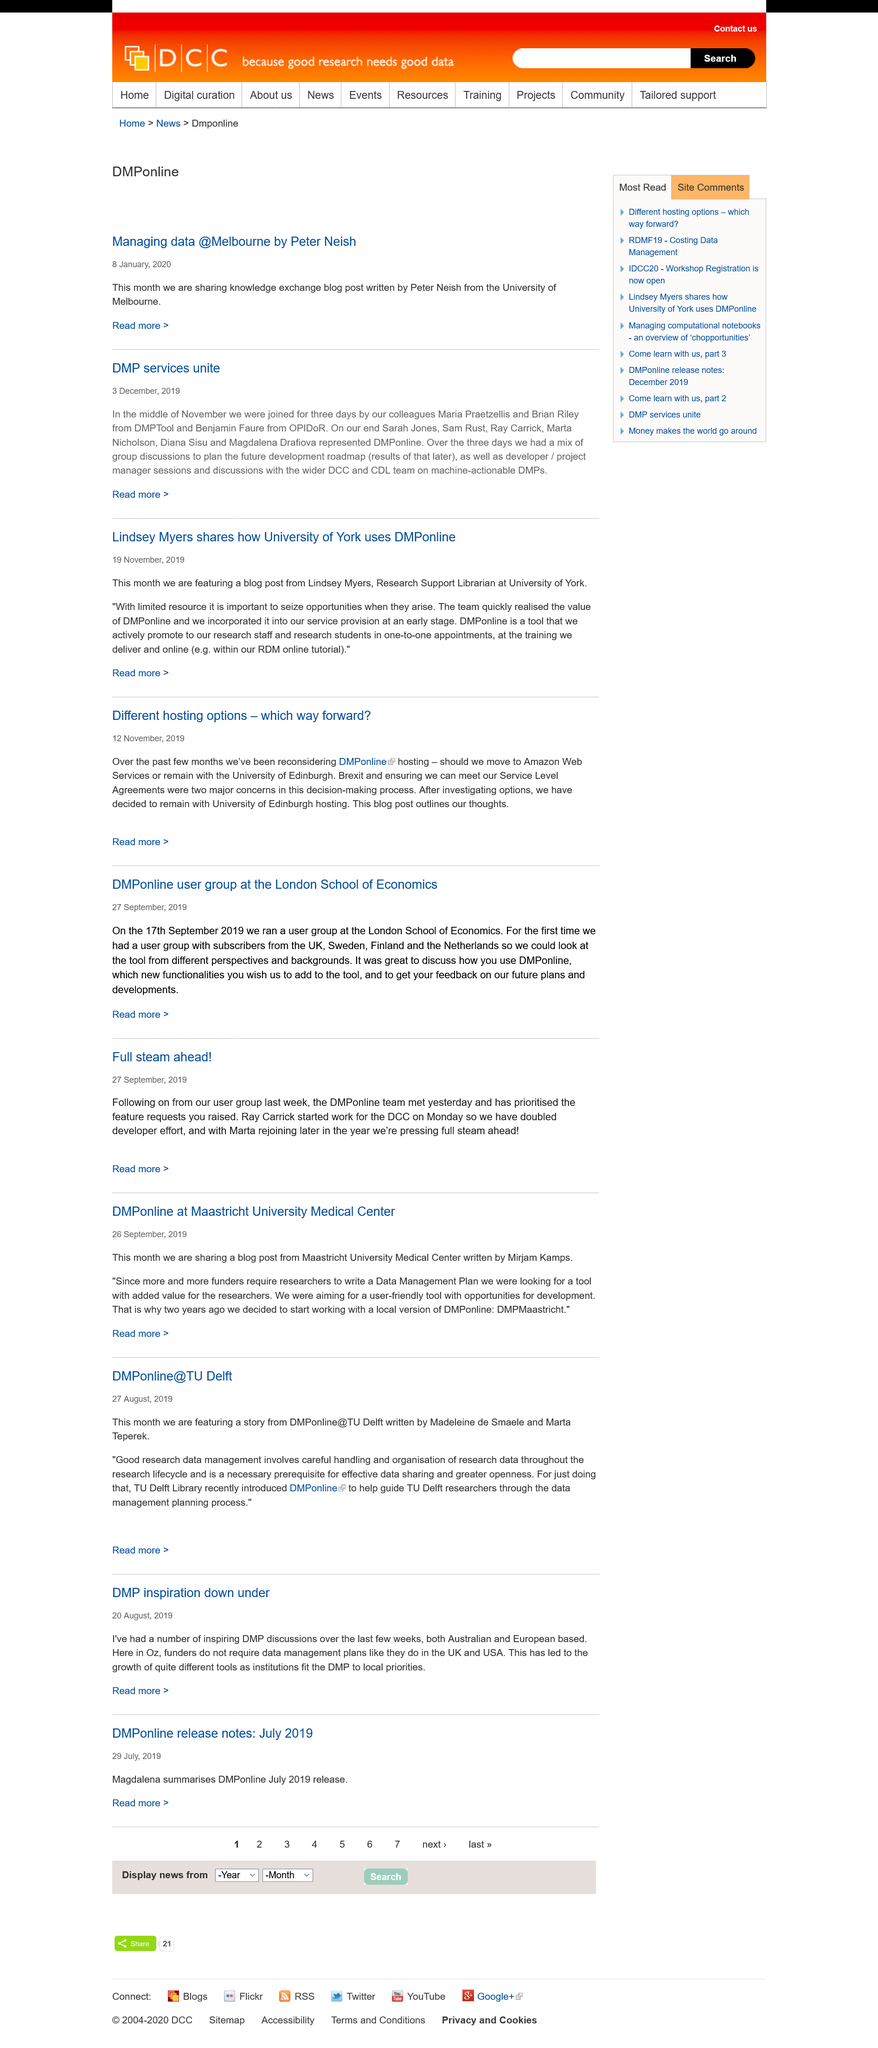Specify some key components in this picture. The University of York is mentioned in the title. The second article was published on November 12th, 2019. The first article was published on November 19th, 2019. 